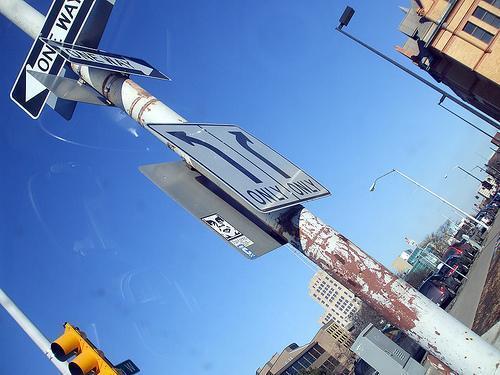How many signs are on the pole?
Give a very brief answer. 6. 